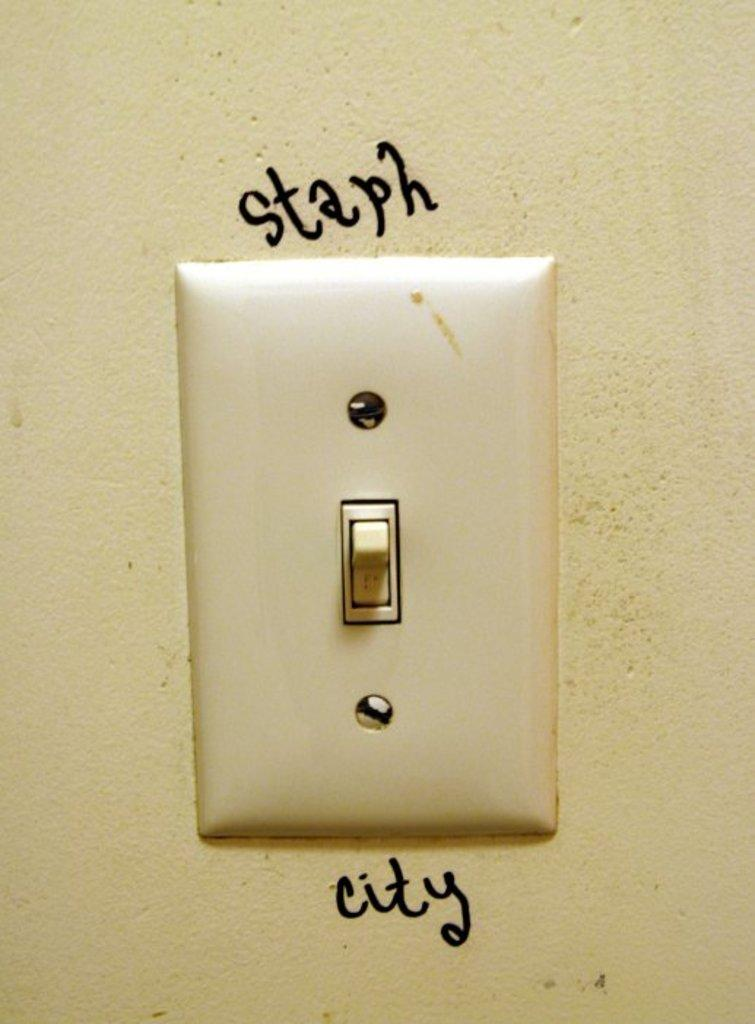<image>
Write a terse but informative summary of the picture. a light switch with the word staph on top and city on the bottom. 